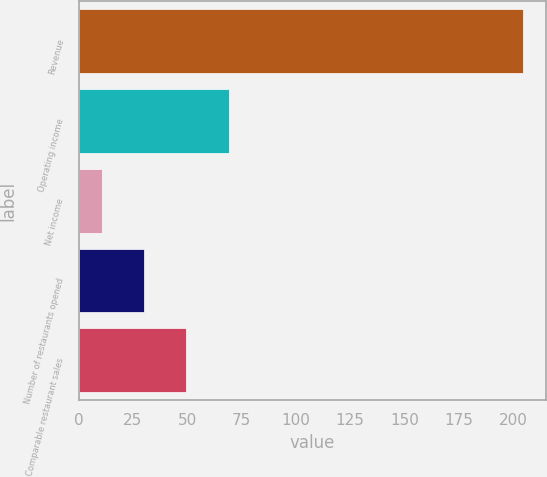<chart> <loc_0><loc_0><loc_500><loc_500><bar_chart><fcel>Revenue<fcel>Operating income<fcel>Net income<fcel>Number of restaurants opened<fcel>Comparable restaurant sales<nl><fcel>204.9<fcel>69.03<fcel>10.8<fcel>30.21<fcel>49.62<nl></chart> 